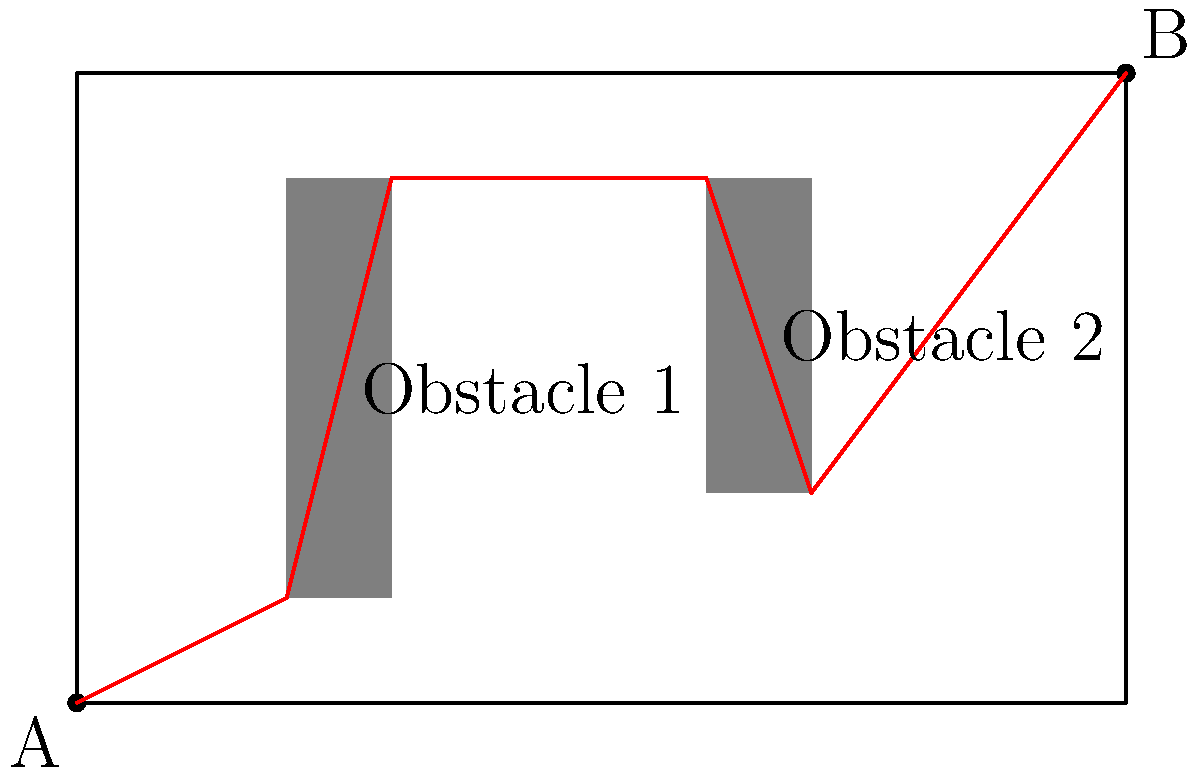As a lieutenant general coordinating troop movement, you need to determine the shortest path for troops to traverse a rectangular field from point A to point B. The field measures 10 units in length and 6 units in width. Two obstacles are present: Obstacle 1 (2x4 units) and Obstacle 2 (1x3 units), as shown in the diagram. Calculate the length of the shortest path from A to B, avoiding the obstacles. To solve this problem, we'll use the following steps:

1) Identify the key points of the path:
   - Start point A (0,0)
   - End point B (10,6)
   - Corner points of obstacles: (2,1), (3,5), (6,5), (7,2)

2) The shortest path will be a series of straight lines connecting these points.

3) Calculate the distances between consecutive points:
   - A to (2,1): $\sqrt{2^2 + 1^2} = \sqrt{5}$
   - (2,1) to (3,5): $\sqrt{1^2 + 4^2} = \sqrt{17}$
   - (3,5) to (6,5): 3
   - (6,5) to (7,2): $\sqrt{1^2 + 3^2} = \sqrt{10}$
   - (7,2) to B: $\sqrt{3^2 + 4^2} = 5$

4) Sum up all the distances:
   $\text{Total distance} = \sqrt{5} + \sqrt{17} + 3 + \sqrt{10} + 5$

5) Simplify:
   $\text{Total distance} = \sqrt{5} + \sqrt{17} + 3 + \sqrt{10} + 5 \approx 14.38$ units
Answer: $\sqrt{5} + \sqrt{17} + 3 + \sqrt{10} + 5$ units (approximately 14.38 units) 